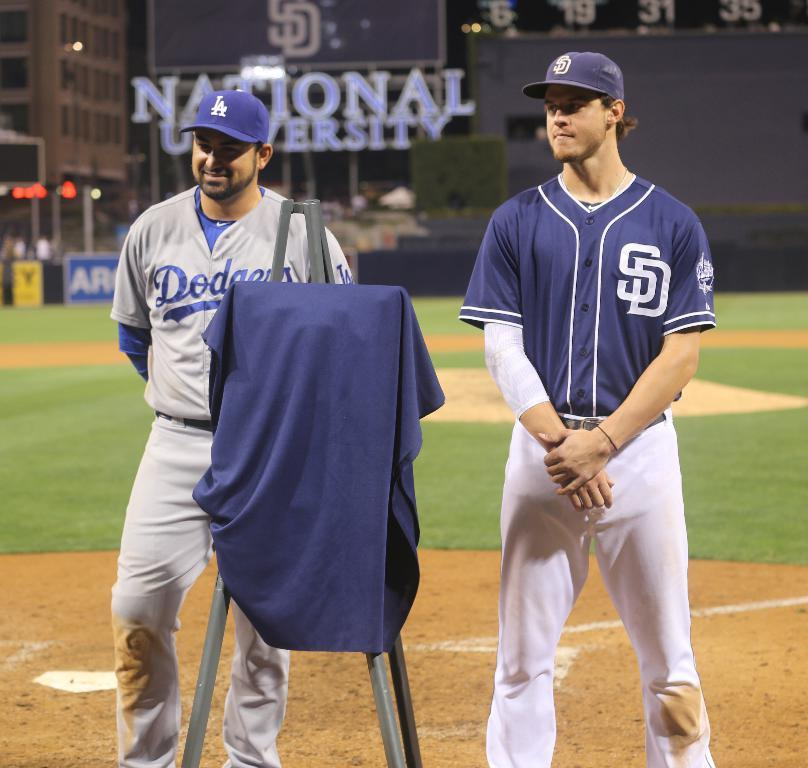<image>
Give a short and clear explanation of the subsequent image. Two men wearing baseball uniforms with the initials SD on them. 